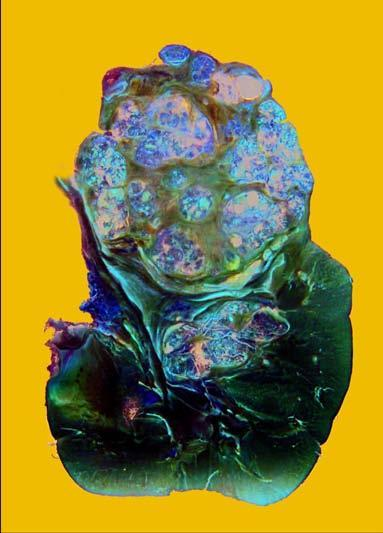what shows a large and tan mass while rest of the kidney has reniform contour?
Answer the question using a single word or phrase. Upper pole of the kidney 